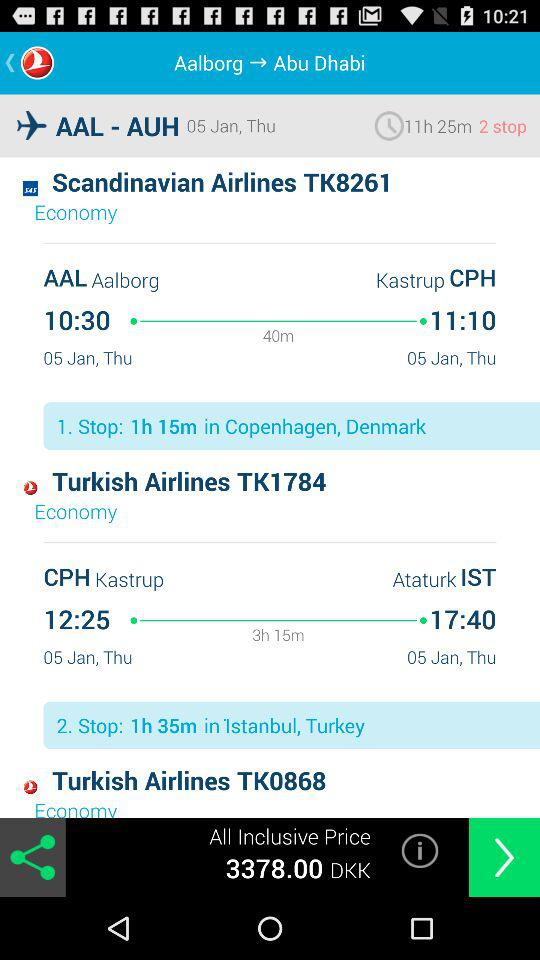How many stops are there?
Answer the question using a single word or phrase. 2 